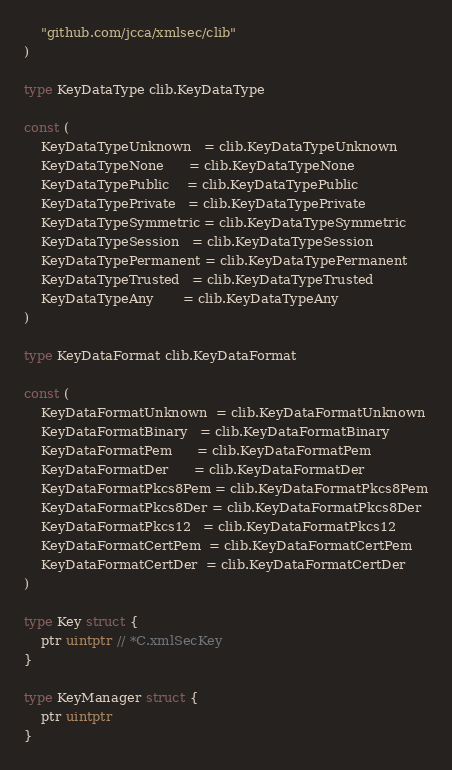Convert code to text. <code><loc_0><loc_0><loc_500><loc_500><_Go_>	"github.com/jcca/xmlsec/clib"
)

type KeyDataType clib.KeyDataType

const (
	KeyDataTypeUnknown   = clib.KeyDataTypeUnknown
	KeyDataTypeNone      = clib.KeyDataTypeNone
	KeyDataTypePublic    = clib.KeyDataTypePublic
	KeyDataTypePrivate   = clib.KeyDataTypePrivate
	KeyDataTypeSymmetric = clib.KeyDataTypeSymmetric
	KeyDataTypeSession   = clib.KeyDataTypeSession
	KeyDataTypePermanent = clib.KeyDataTypePermanent
	KeyDataTypeTrusted   = clib.KeyDataTypeTrusted
	KeyDataTypeAny       = clib.KeyDataTypeAny
)

type KeyDataFormat clib.KeyDataFormat

const (
	KeyDataFormatUnknown  = clib.KeyDataFormatUnknown
	KeyDataFormatBinary   = clib.KeyDataFormatBinary
	KeyDataFormatPem      = clib.KeyDataFormatPem
	KeyDataFormatDer      = clib.KeyDataFormatDer
	KeyDataFormatPkcs8Pem = clib.KeyDataFormatPkcs8Pem
	KeyDataFormatPkcs8Der = clib.KeyDataFormatPkcs8Der
	KeyDataFormatPkcs12   = clib.KeyDataFormatPkcs12
	KeyDataFormatCertPem  = clib.KeyDataFormatCertPem
	KeyDataFormatCertDer  = clib.KeyDataFormatCertDer
)

type Key struct {
	ptr uintptr // *C.xmlSecKey
}

type KeyManager struct {
	ptr uintptr
}
</code> 